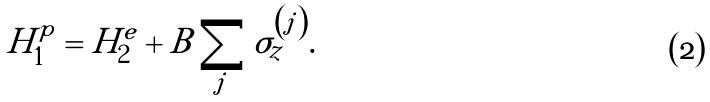Convert formula to latex. <formula><loc_0><loc_0><loc_500><loc_500>H _ { 1 } ^ { p } = H _ { 2 } ^ { e } + B \sum _ { j } \sigma _ { z } ^ { \left ( j \right ) } .</formula> 